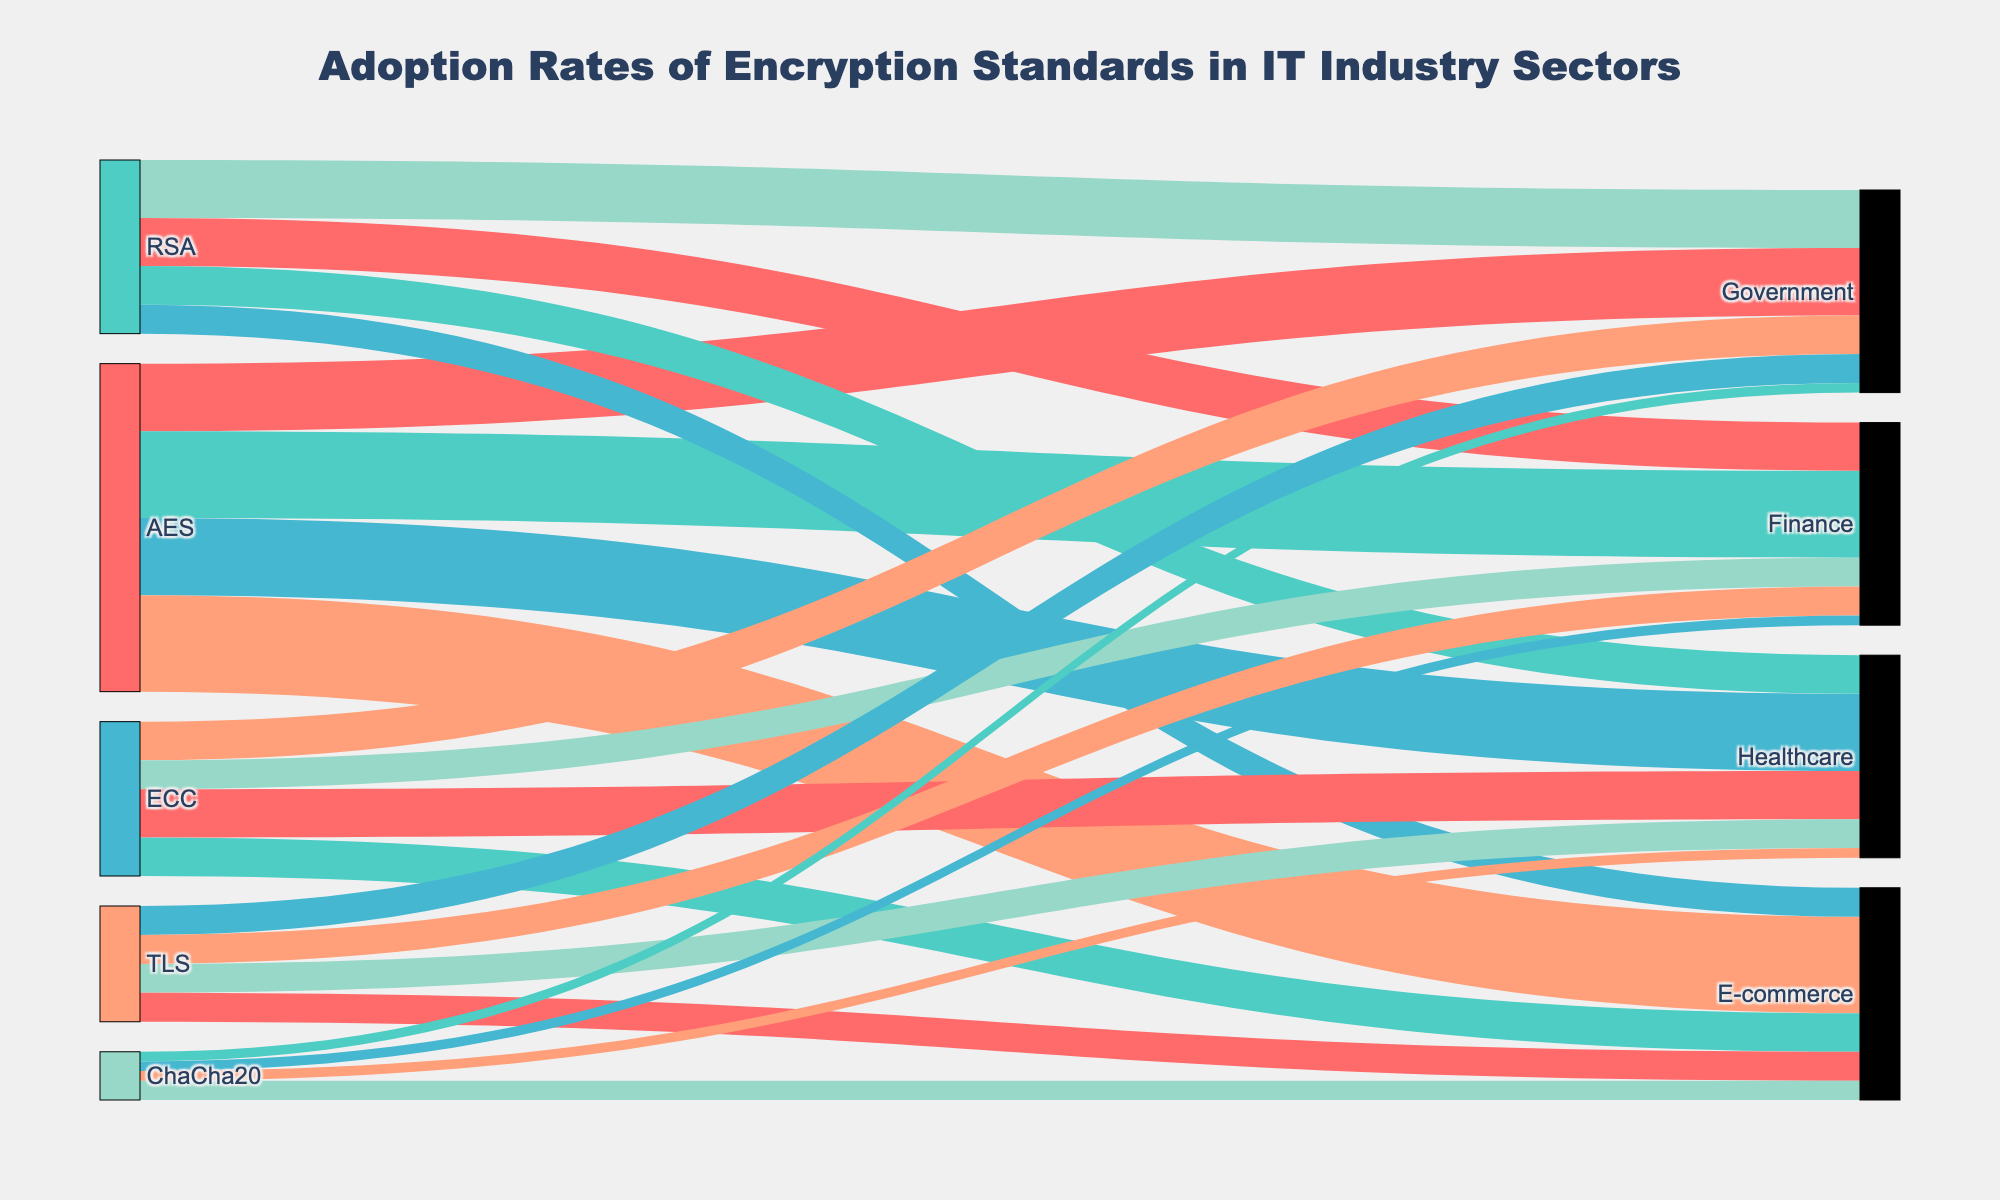What is the title of the Sankey Diagram? The title is positioned at the top center of the figure. It reads "Adoption Rates of Encryption Standards in IT Industry Sectors."
Answer: Adoption Rates of Encryption Standards in IT Industry Sectors Which encryption standard is most widely adopted by the E-commerce sector? To find this, look at the connections leading to the E-commerce node and identify the one with the highest value. "AES -> E-commerce" has a value of 50, which is the highest among the connections.
Answer: AES How many sectors have an adoption rate of more than 20 for the RSA standard? We need to check the values for RSA connecting to different sectors. They are: Government (30), Finance (25), Healthcare (20), and E-commerce (15). Only Government and Finance have adoption rates above 20.
Answer: 2 What is the total adoption rate for TLS across all sectors? Sum the values for TLS across all sectors: Government (15) + Finance (15) + Healthcare (15) + E-commerce (15). The total is 15 + 15 + 15 + 15 = 60.
Answer: 60 Compare the adoption rates of ECC and RSA in the Healthcare sector. Which one is higher and by how much? Check the values connecting ECC -> Healthcare and RSA -> Healthcare. ECC -> Healthcare has a value of 25, while RSA -> Healthcare has a value of 20. ECC is higher by 25 - 20 = 5.
Answer: ECC by 5 Which sectors have equal adoption rates for the ChaCha20 encryption standard? For this, look at the values connecting ChaCha20 to various sectors. They are Government (5), Finance (5), Healthcare (5), and E-commerce (10). Government, Finance, and Healthcare have equal adoption rates.
Answer: Government, Finance, Healthcare What is the combined adoption rate for AES and ECC in the Government sector? Add the values for AES -> Government and ECC -> Government. AES -> Government is 35 and ECC -> Government is 20. Combined, they are 35 + 20 = 55.
Answer: 55 How does the adoption rate of AES in the Finance sector compare to that in the Government sector? Check the values connecting AES to these sectors. AES -> Finance has a value of 45, while AES -> Government has a value of 35. AES adoption in Finance is higher by 45 - 35 = 10.
Answer: Higher by 10 Which encryption standard has the least total adoption across all sectors? We need to sum the values for each encryption standard and compare. Totals are: AES (35+45+40+50=170), RSA (30+25+20+15=90), ECC (20+15+25+20=80), TLS (15+15+15+15=60), ChaCha20 (5+5+5+10=25). ChaCha20 has the least total adoption at 25.
Answer: ChaCha20 